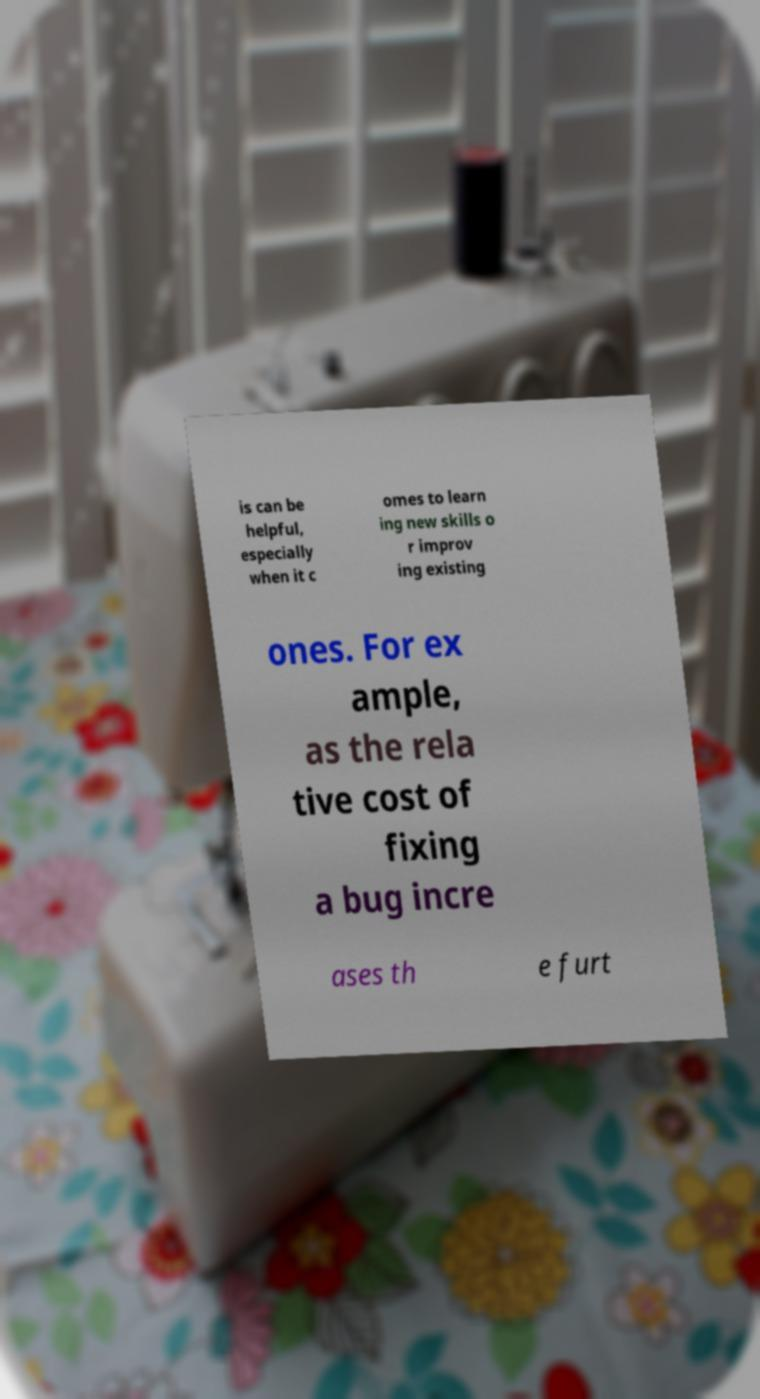Can you accurately transcribe the text from the provided image for me? is can be helpful, especially when it c omes to learn ing new skills o r improv ing existing ones. For ex ample, as the rela tive cost of fixing a bug incre ases th e furt 